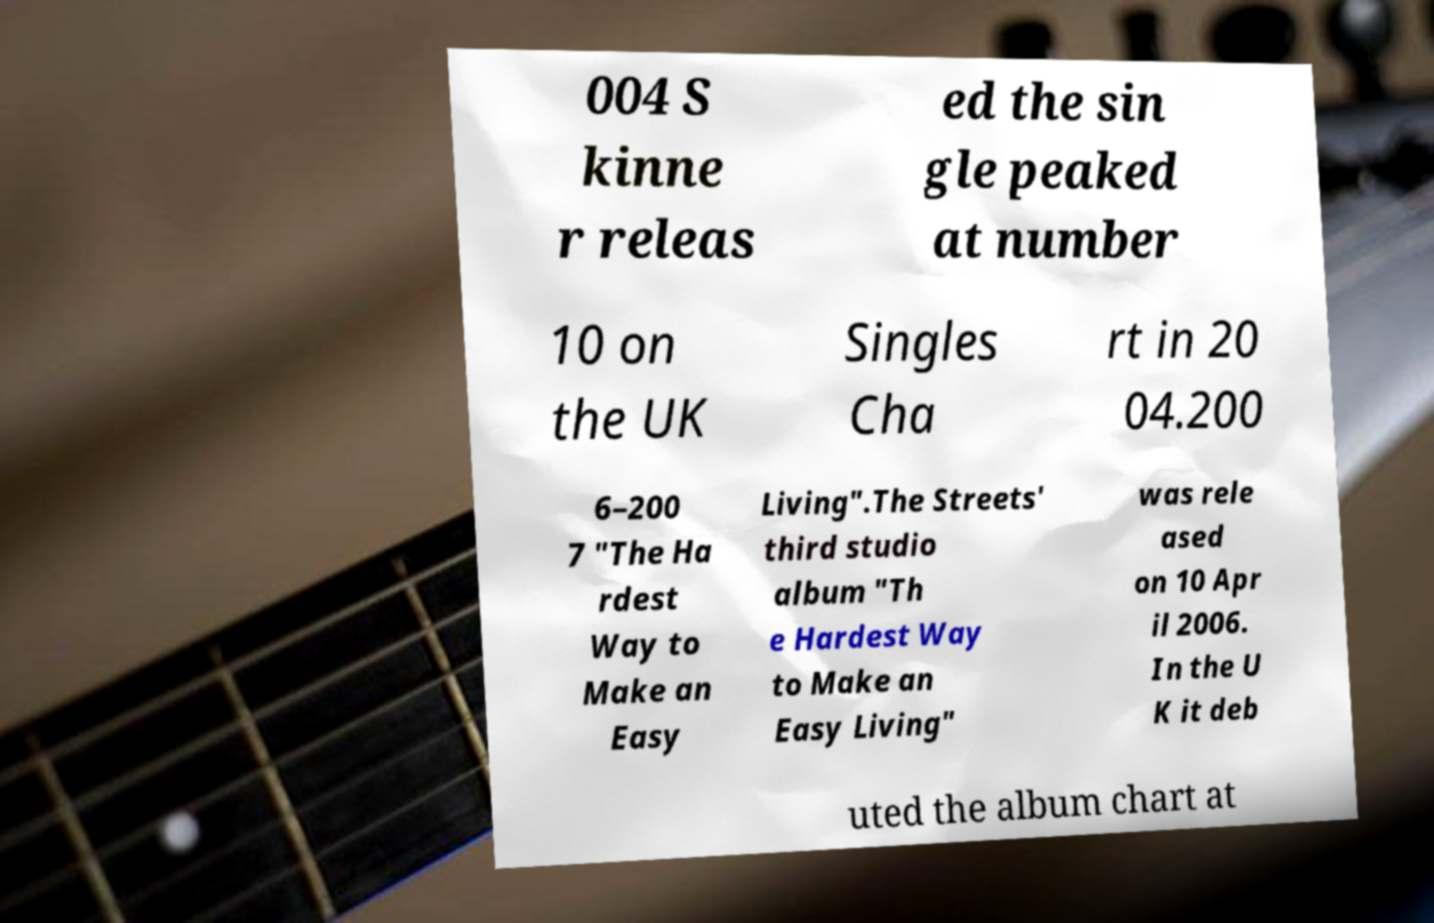I need the written content from this picture converted into text. Can you do that? 004 S kinne r releas ed the sin gle peaked at number 10 on the UK Singles Cha rt in 20 04.200 6–200 7 "The Ha rdest Way to Make an Easy Living".The Streets' third studio album "Th e Hardest Way to Make an Easy Living" was rele ased on 10 Apr il 2006. In the U K it deb uted the album chart at 